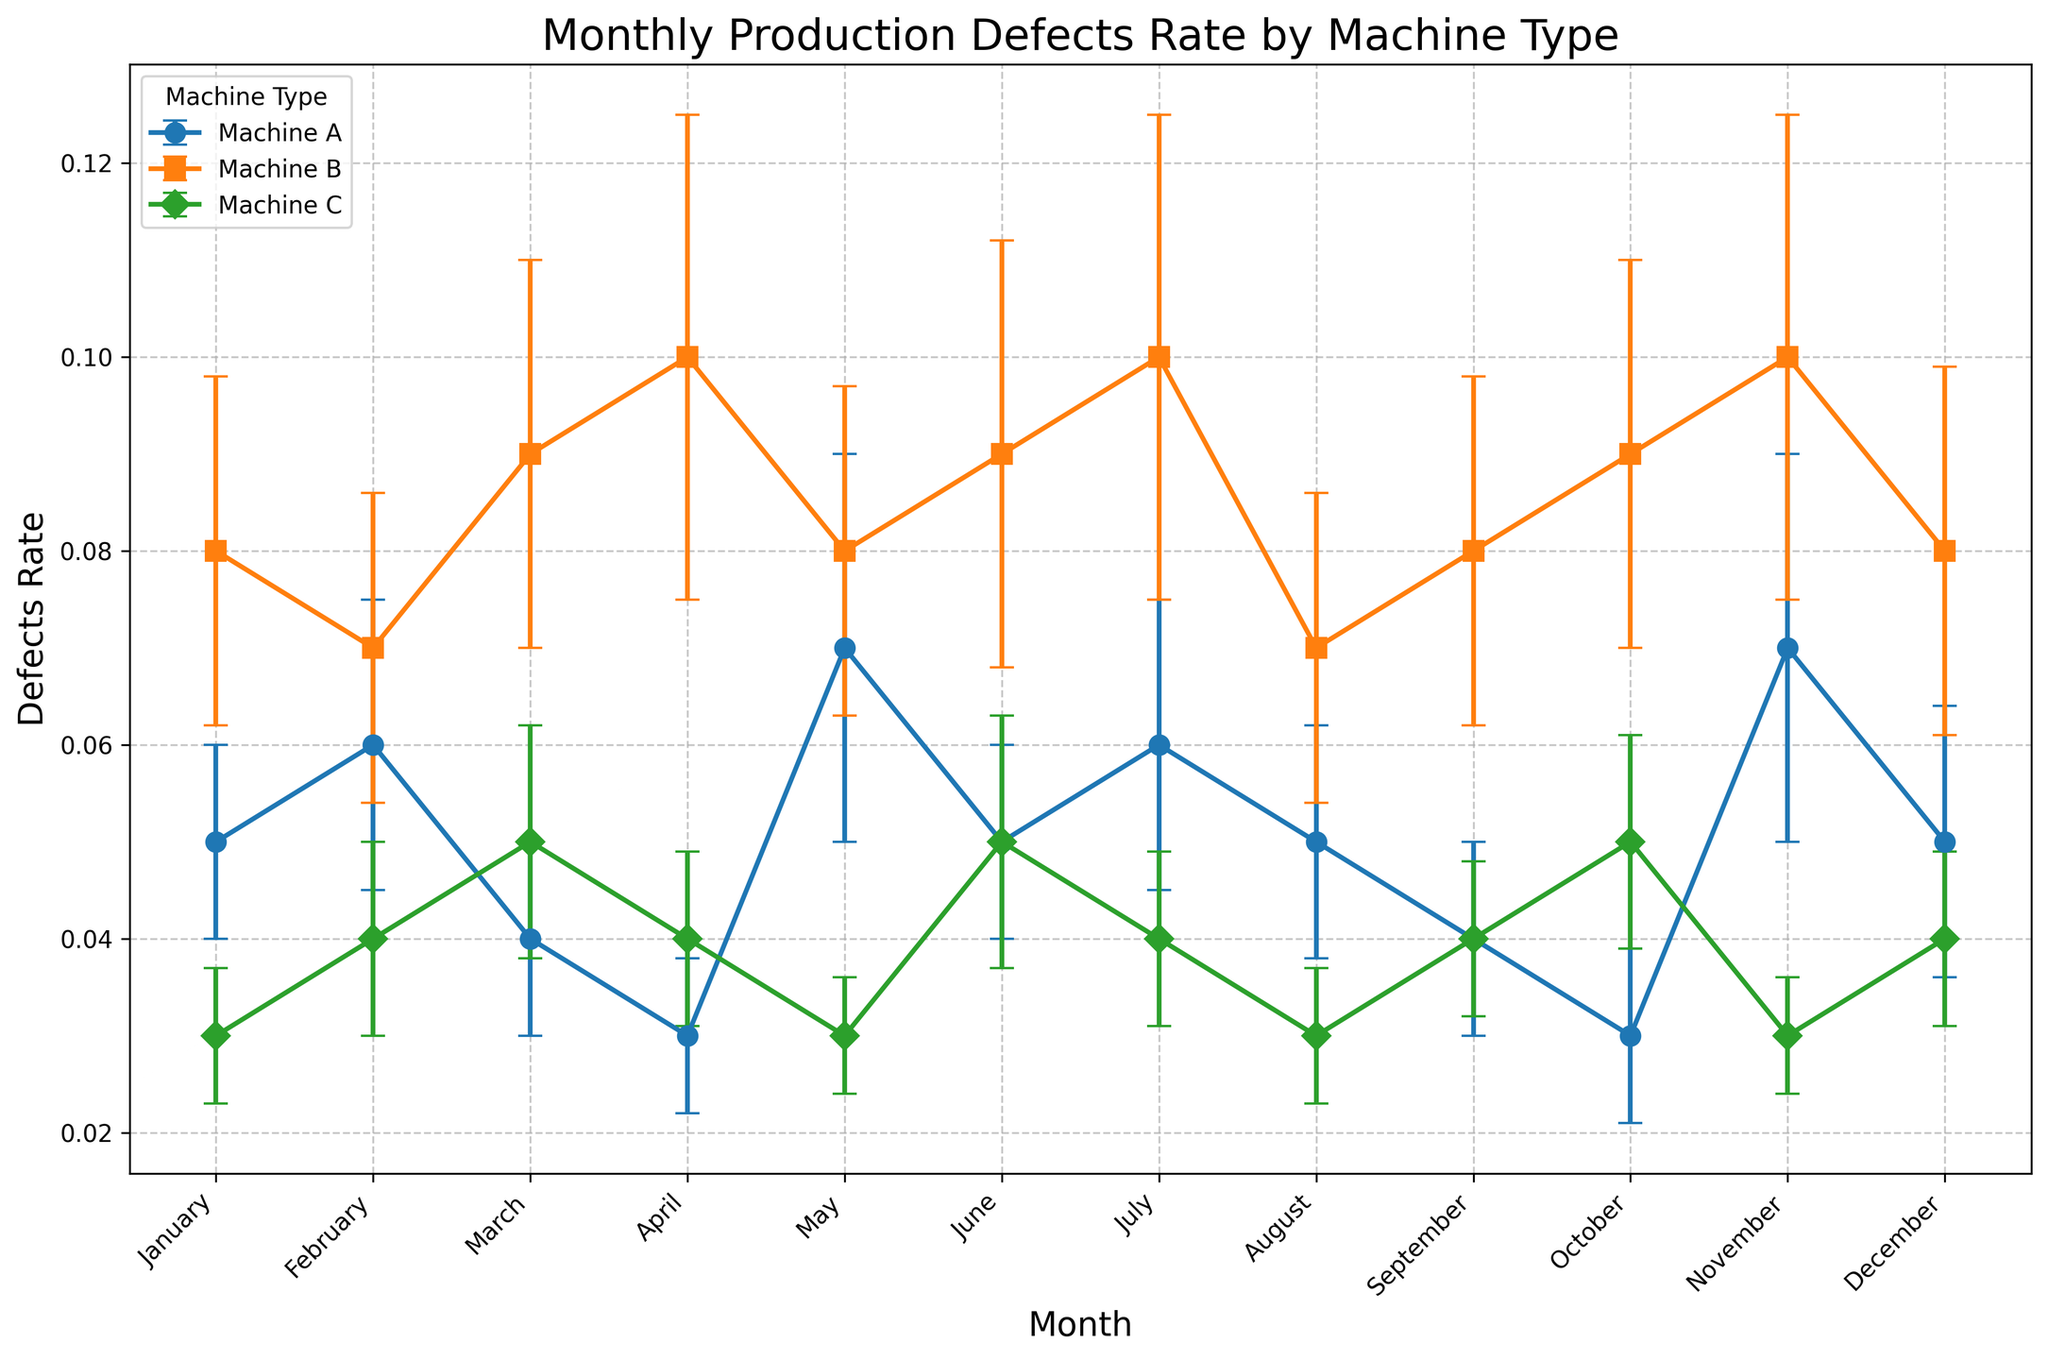Which machine type had the highest defect rate in April? By observing the chart, we can see that Machine B had the highest defect rate in April, with a defect rate of 0.1.
Answer: Machine B What is the average defect rate for Machine A over the year? To find the average defect rate for Machine A, add up all the defect rates for each month and then divide by the number of months (12). The sum of defect rates is 0.05 + 0.06 + 0.04 + 0.03 + 0.07 + 0.05 + 0.06 + 0.05 + 0.04 + 0.03 + 0.07 + 0.05 = 0.6. So, the average is 0.6/12 = 0.05.
Answer: 0.05 In which month did Machine C have its highest defect rate? By looking at the chart, the peak defect rate for Machine C occurred in March and October, both having a defect rate of 0.05.
Answer: March and October How does the defect rate of Machine A in February compare to that of Machine B in February? By observing the chart, Machine A's defect rate in February is 0.06 while Machine B's defect rate in February is 0.07. Hence, Machine B's defect rate is higher than Machine A's in February.
Answer: Machine B's defect rate is higher What is the total defect rate for Machines B and C combined in June? To find the total defect rate, sum the defect rates for Machine B and Machine C in June. Machine B's rate is 0.09 and Machine C's rate is 0.05. Therefore, 0.09 + 0.05 = 0.14.
Answer: 0.14 Which machine has the most consistent defect rate throughout the year? By observing the error bars (standard deviation) in the chart, Machine C generally has smaller error bars. This indicates that Machine C has the most consistent defect rate throughout the year.
Answer: Machine C 